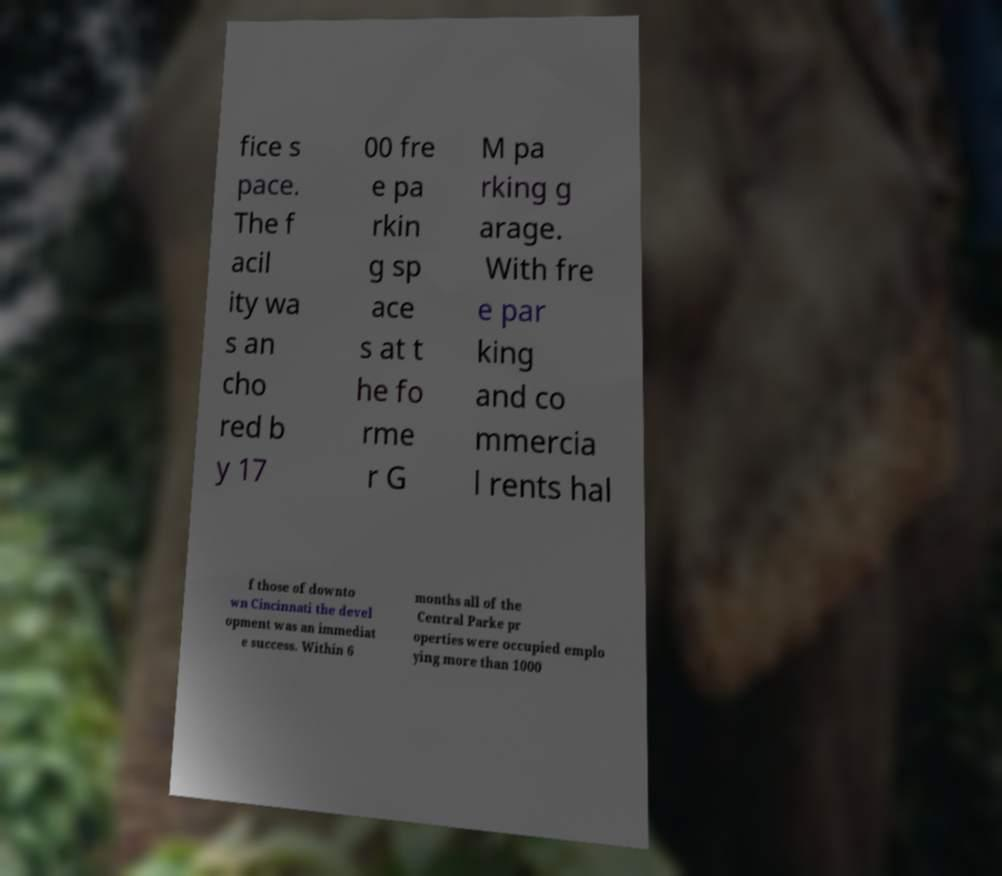I need the written content from this picture converted into text. Can you do that? fice s pace. The f acil ity wa s an cho red b y 17 00 fre e pa rkin g sp ace s at t he fo rme r G M pa rking g arage. With fre e par king and co mmercia l rents hal f those of downto wn Cincinnati the devel opment was an immediat e success. Within 6 months all of the Central Parke pr operties were occupied emplo ying more than 1000 